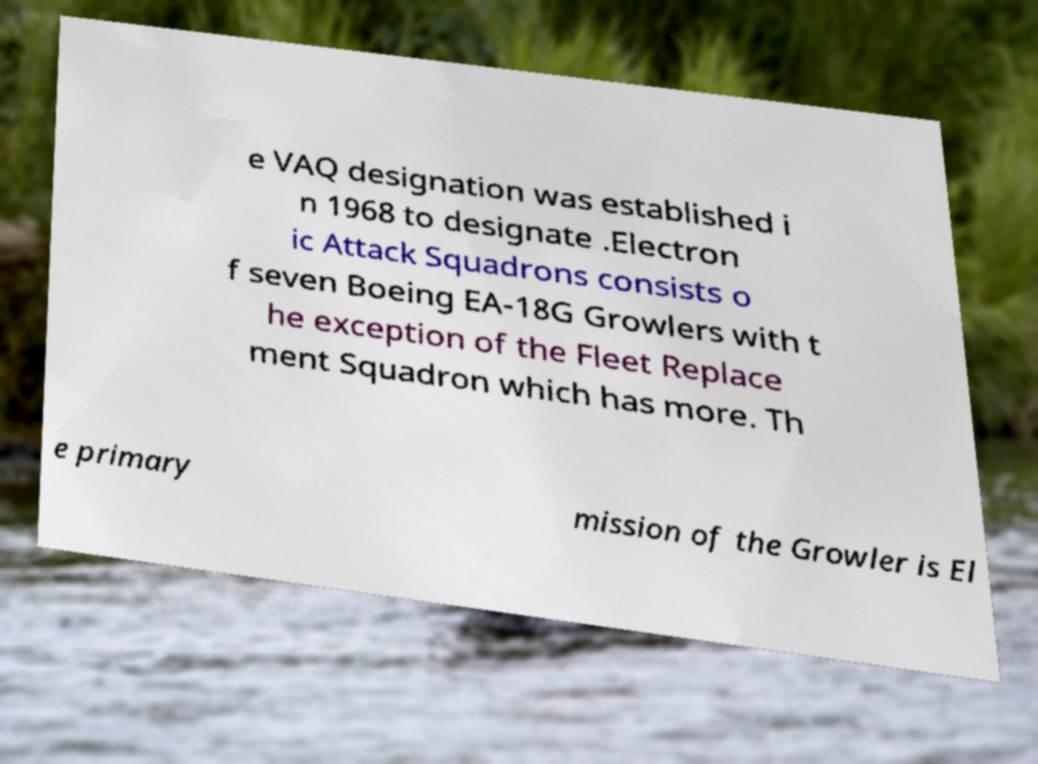Please read and relay the text visible in this image. What does it say? e VAQ designation was established i n 1968 to designate .Electron ic Attack Squadrons consists o f seven Boeing EA-18G Growlers with t he exception of the Fleet Replace ment Squadron which has more. Th e primary mission of the Growler is El 